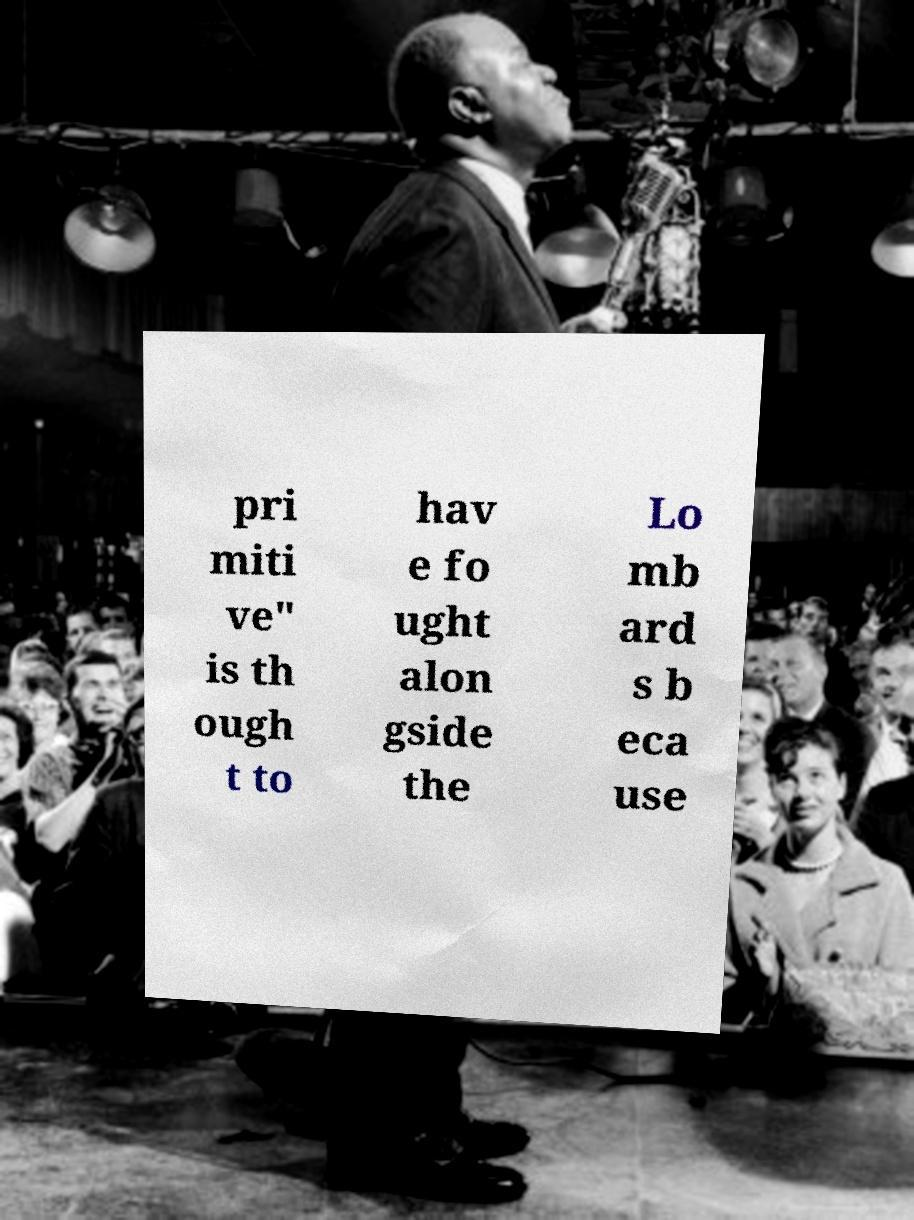What messages or text are displayed in this image? I need them in a readable, typed format. pri miti ve" is th ough t to hav e fo ught alon gside the Lo mb ard s b eca use 